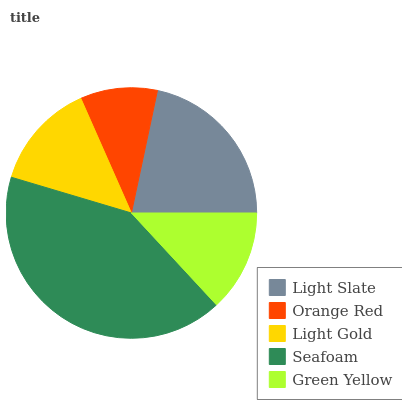Is Orange Red the minimum?
Answer yes or no. Yes. Is Seafoam the maximum?
Answer yes or no. Yes. Is Light Gold the minimum?
Answer yes or no. No. Is Light Gold the maximum?
Answer yes or no. No. Is Light Gold greater than Orange Red?
Answer yes or no. Yes. Is Orange Red less than Light Gold?
Answer yes or no. Yes. Is Orange Red greater than Light Gold?
Answer yes or no. No. Is Light Gold less than Orange Red?
Answer yes or no. No. Is Light Gold the high median?
Answer yes or no. Yes. Is Light Gold the low median?
Answer yes or no. Yes. Is Green Yellow the high median?
Answer yes or no. No. Is Green Yellow the low median?
Answer yes or no. No. 